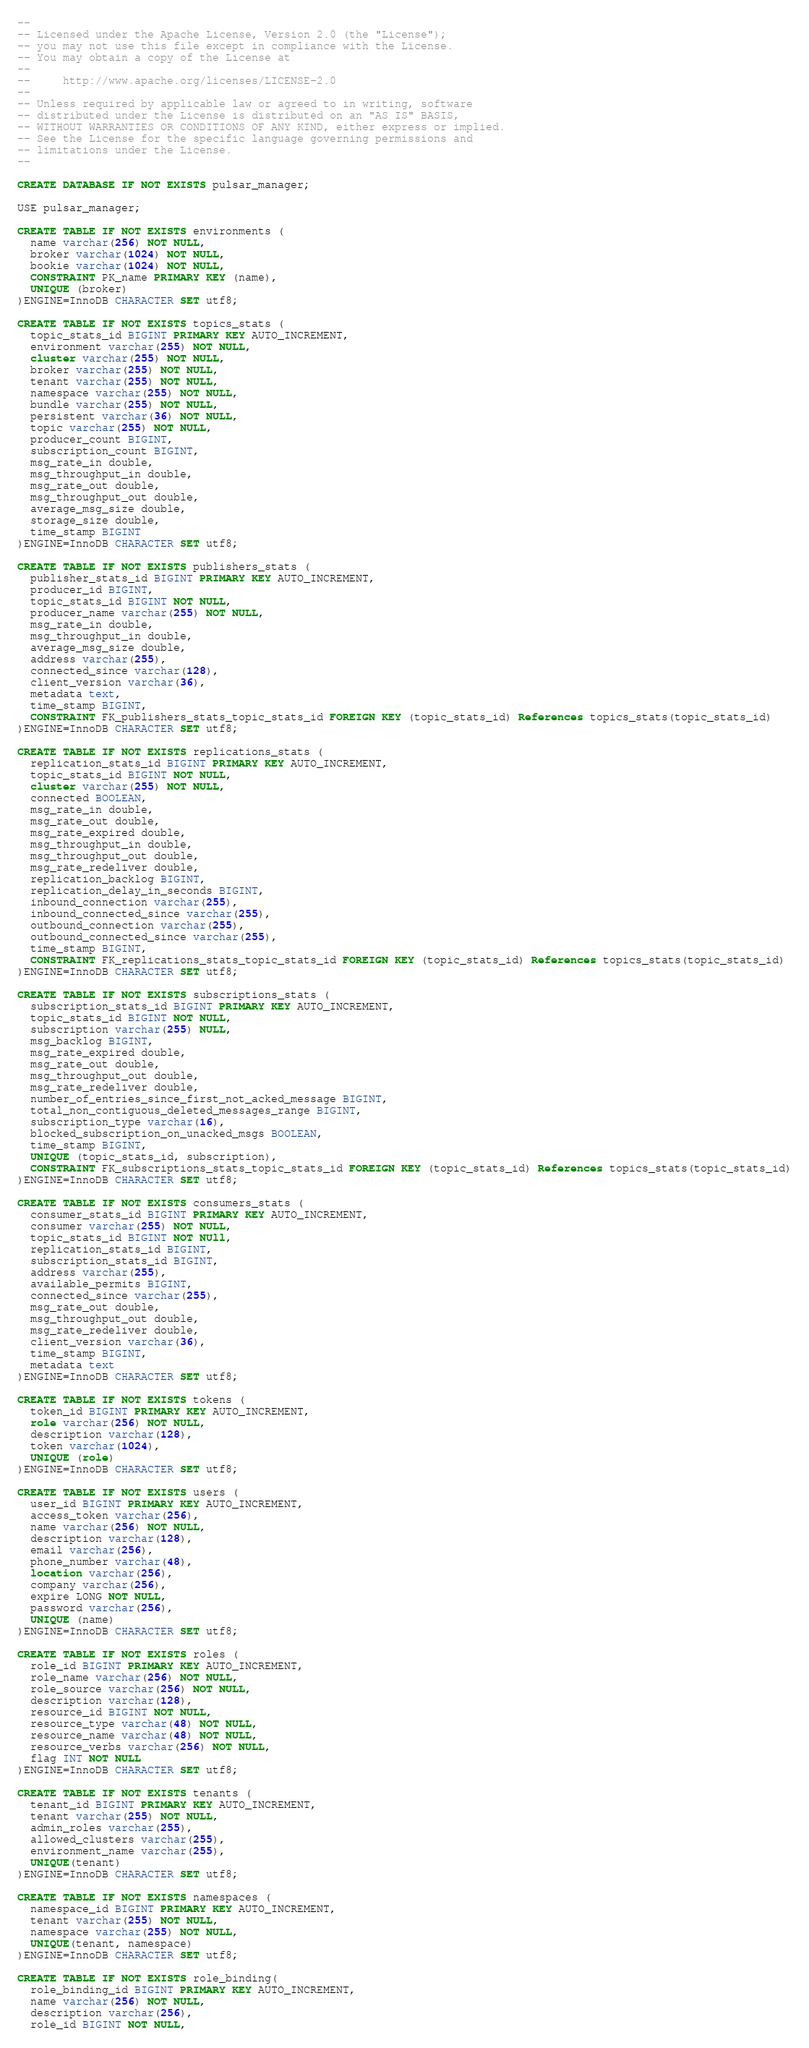Convert code to text. <code><loc_0><loc_0><loc_500><loc_500><_SQL_>--
-- Licensed under the Apache License, Version 2.0 (the "License");
-- you may not use this file except in compliance with the License.
-- You may obtain a copy of the License at
--
--     http://www.apache.org/licenses/LICENSE-2.0
--
-- Unless required by applicable law or agreed to in writing, software
-- distributed under the License is distributed on an "AS IS" BASIS,
-- WITHOUT WARRANTIES OR CONDITIONS OF ANY KIND, either express or implied.
-- See the License for the specific language governing permissions and
-- limitations under the License.
--

CREATE DATABASE IF NOT EXISTS pulsar_manager;

USE pulsar_manager;

CREATE TABLE IF NOT EXISTS environments (
  name varchar(256) NOT NULL,
  broker varchar(1024) NOT NULL,
  bookie varchar(1024) NOT NULL,
  CONSTRAINT PK_name PRIMARY KEY (name),
  UNIQUE (broker)
)ENGINE=InnoDB CHARACTER SET utf8;

CREATE TABLE IF NOT EXISTS topics_stats (
  topic_stats_id BIGINT PRIMARY KEY AUTO_INCREMENT,
  environment varchar(255) NOT NULL,
  cluster varchar(255) NOT NULL,
  broker varchar(255) NOT NULL,
  tenant varchar(255) NOT NULL,
  namespace varchar(255) NOT NULL,
  bundle varchar(255) NOT NULL,
  persistent varchar(36) NOT NULL,
  topic varchar(255) NOT NULL,
  producer_count BIGINT,
  subscription_count BIGINT,
  msg_rate_in double,
  msg_throughput_in double,
  msg_rate_out double,
  msg_throughput_out double,
  average_msg_size double,
  storage_size double,
  time_stamp BIGINT
)ENGINE=InnoDB CHARACTER SET utf8;

CREATE TABLE IF NOT EXISTS publishers_stats (
  publisher_stats_id BIGINT PRIMARY KEY AUTO_INCREMENT,
  producer_id BIGINT,
  topic_stats_id BIGINT NOT NULL,
  producer_name varchar(255) NOT NULL,
  msg_rate_in double,
  msg_throughput_in double,
  average_msg_size double,
  address varchar(255),
  connected_since varchar(128),
  client_version varchar(36),
  metadata text,
  time_stamp BIGINT,
  CONSTRAINT FK_publishers_stats_topic_stats_id FOREIGN KEY (topic_stats_id) References topics_stats(topic_stats_id)
)ENGINE=InnoDB CHARACTER SET utf8;

CREATE TABLE IF NOT EXISTS replications_stats (
  replication_stats_id BIGINT PRIMARY KEY AUTO_INCREMENT,
  topic_stats_id BIGINT NOT NULL,
  cluster varchar(255) NOT NULL,
  connected BOOLEAN,
  msg_rate_in double,
  msg_rate_out double,
  msg_rate_expired double,
  msg_throughput_in double,
  msg_throughput_out double,
  msg_rate_redeliver double,
  replication_backlog BIGINT,
  replication_delay_in_seconds BIGINT,
  inbound_connection varchar(255),
  inbound_connected_since varchar(255),
  outbound_connection varchar(255),
  outbound_connected_since varchar(255),
  time_stamp BIGINT,
  CONSTRAINT FK_replications_stats_topic_stats_id FOREIGN KEY (topic_stats_id) References topics_stats(topic_stats_id)
)ENGINE=InnoDB CHARACTER SET utf8;

CREATE TABLE IF NOT EXISTS subscriptions_stats (
  subscription_stats_id BIGINT PRIMARY KEY AUTO_INCREMENT,
  topic_stats_id BIGINT NOT NULL,
  subscription varchar(255) NULL,
  msg_backlog BIGINT,
  msg_rate_expired double,
  msg_rate_out double,
  msg_throughput_out double,
  msg_rate_redeliver double,
  number_of_entries_since_first_not_acked_message BIGINT,
  total_non_contiguous_deleted_messages_range BIGINT,
  subscription_type varchar(16),
  blocked_subscription_on_unacked_msgs BOOLEAN,
  time_stamp BIGINT,
  UNIQUE (topic_stats_id, subscription),
  CONSTRAINT FK_subscriptions_stats_topic_stats_id FOREIGN KEY (topic_stats_id) References topics_stats(topic_stats_id)
)ENGINE=InnoDB CHARACTER SET utf8;

CREATE TABLE IF NOT EXISTS consumers_stats (
  consumer_stats_id BIGINT PRIMARY KEY AUTO_INCREMENT,
  consumer varchar(255) NOT NULL,
  topic_stats_id BIGINT NOT NUll,
  replication_stats_id BIGINT,
  subscription_stats_id BIGINT,
  address varchar(255),
  available_permits BIGINT,
  connected_since varchar(255),
  msg_rate_out double,
  msg_throughput_out double,
  msg_rate_redeliver double,
  client_version varchar(36),
  time_stamp BIGINT,
  metadata text
)ENGINE=InnoDB CHARACTER SET utf8;

CREATE TABLE IF NOT EXISTS tokens (
  token_id BIGINT PRIMARY KEY AUTO_INCREMENT,
  role varchar(256) NOT NULL,
  description varchar(128),
  token varchar(1024),
  UNIQUE (role)
)ENGINE=InnoDB CHARACTER SET utf8;

CREATE TABLE IF NOT EXISTS users (
  user_id BIGINT PRIMARY KEY AUTO_INCREMENT,
  access_token varchar(256),
  name varchar(256) NOT NULL,
  description varchar(128),
  email varchar(256),
  phone_number varchar(48),
  location varchar(256),
  company varchar(256),
  expire LONG NOT NULL,
  password varchar(256),
  UNIQUE (name)
)ENGINE=InnoDB CHARACTER SET utf8;

CREATE TABLE IF NOT EXISTS roles (
  role_id BIGINT PRIMARY KEY AUTO_INCREMENT,
  role_name varchar(256) NOT NULL,
  role_source varchar(256) NOT NULL,
  description varchar(128),
  resource_id BIGINT NOT NULL,
  resource_type varchar(48) NOT NULL,
  resource_name varchar(48) NOT NULL,
  resource_verbs varchar(256) NOT NULL,
  flag INT NOT NULL
)ENGINE=InnoDB CHARACTER SET utf8;

CREATE TABLE IF NOT EXISTS tenants (
  tenant_id BIGINT PRIMARY KEY AUTO_INCREMENT,
  tenant varchar(255) NOT NULL,
  admin_roles varchar(255),
  allowed_clusters varchar(255),
  environment_name varchar(255),
  UNIQUE(tenant)
)ENGINE=InnoDB CHARACTER SET utf8;

CREATE TABLE IF NOT EXISTS namespaces (
  namespace_id BIGINT PRIMARY KEY AUTO_INCREMENT,
  tenant varchar(255) NOT NULL,
  namespace varchar(255) NOT NULL,
  UNIQUE(tenant, namespace)
)ENGINE=InnoDB CHARACTER SET utf8;

CREATE TABLE IF NOT EXISTS role_binding(
  role_binding_id BIGINT PRIMARY KEY AUTO_INCREMENT,
  name varchar(256) NOT NULL,
  description varchar(256),
  role_id BIGINT NOT NULL,</code> 